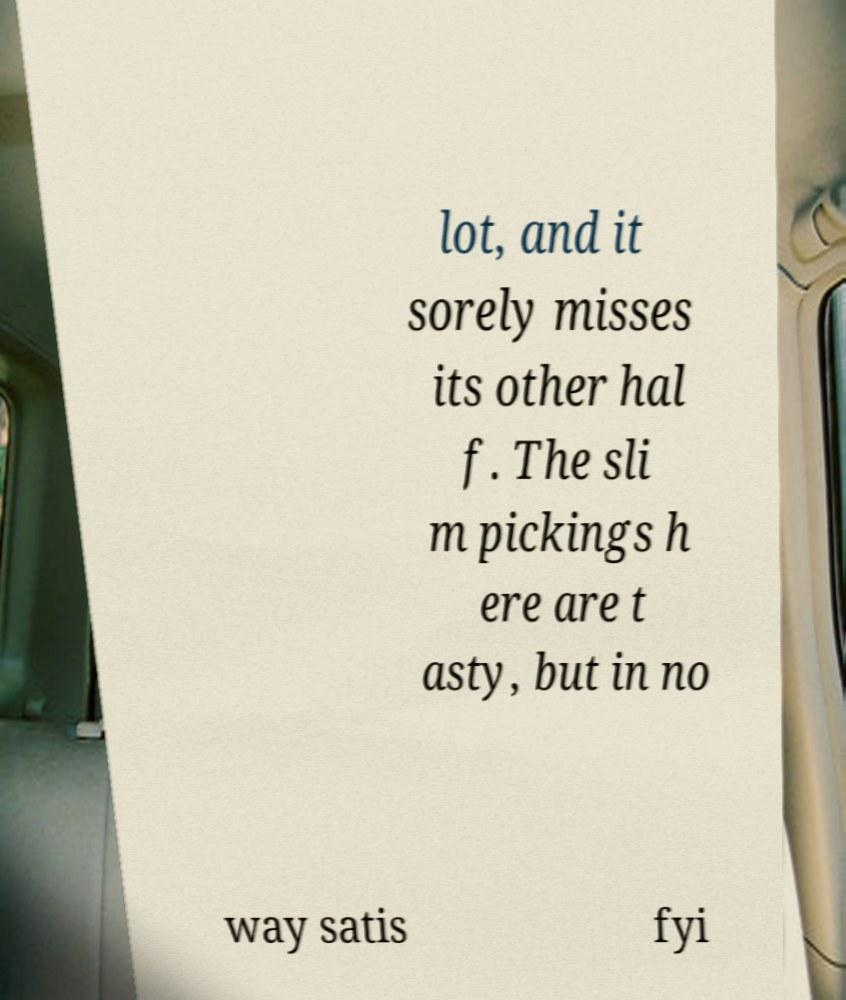There's text embedded in this image that I need extracted. Can you transcribe it verbatim? lot, and it sorely misses its other hal f. The sli m pickings h ere are t asty, but in no way satis fyi 